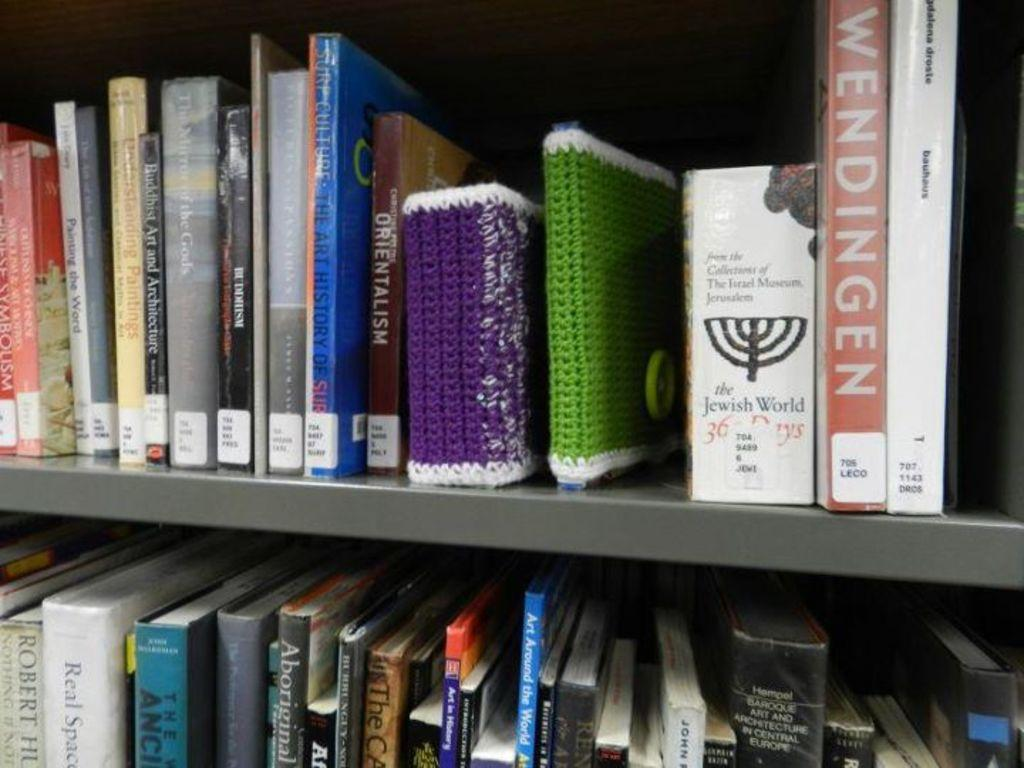<image>
Provide a brief description of the given image. A shelf of books with one being about the Jewish world. 